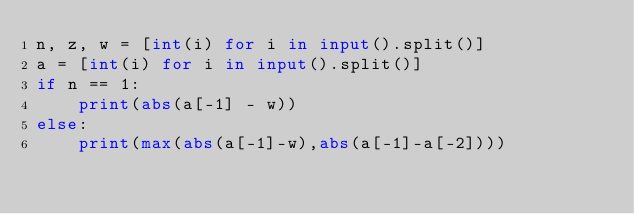Convert code to text. <code><loc_0><loc_0><loc_500><loc_500><_Python_>n, z, w = [int(i) for i in input().split()]
a = [int(i) for i in input().split()]
if n == 1:
    print(abs(a[-1] - w))
else:
    print(max(abs(a[-1]-w),abs(a[-1]-a[-2])))</code> 